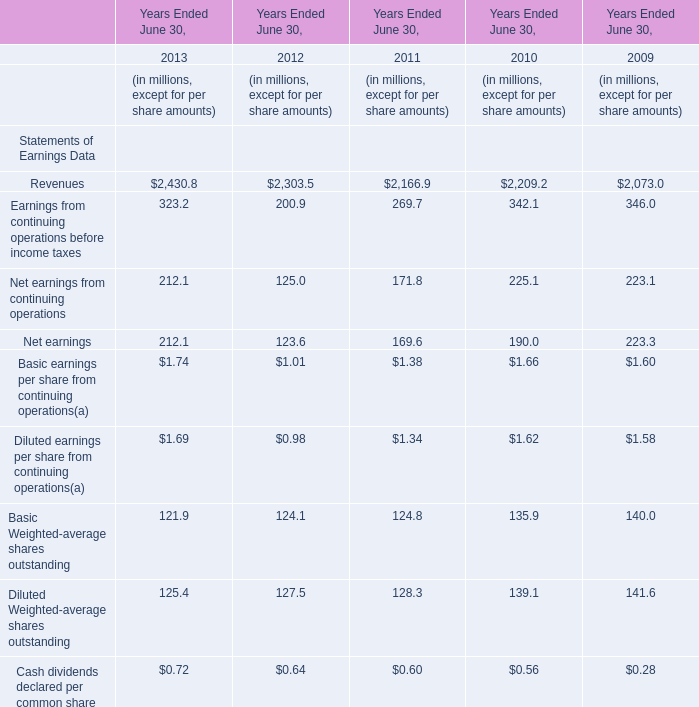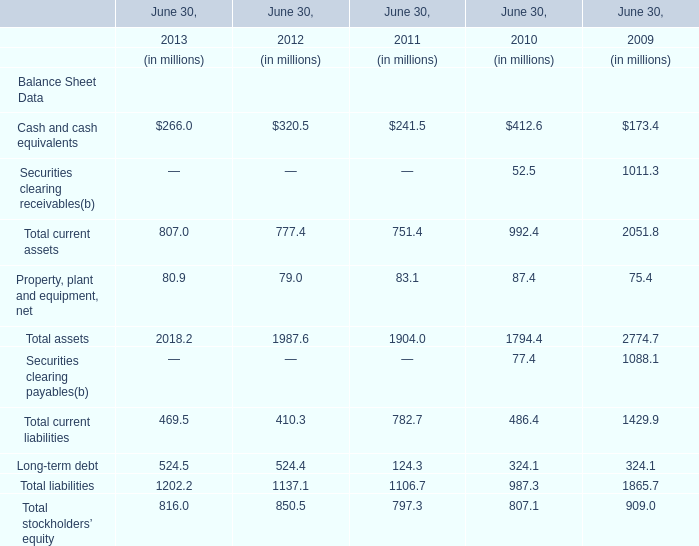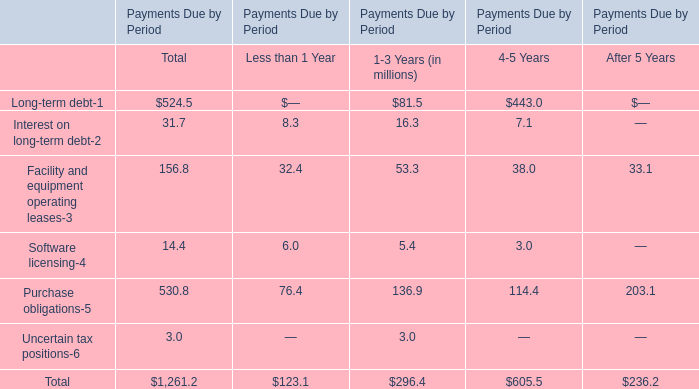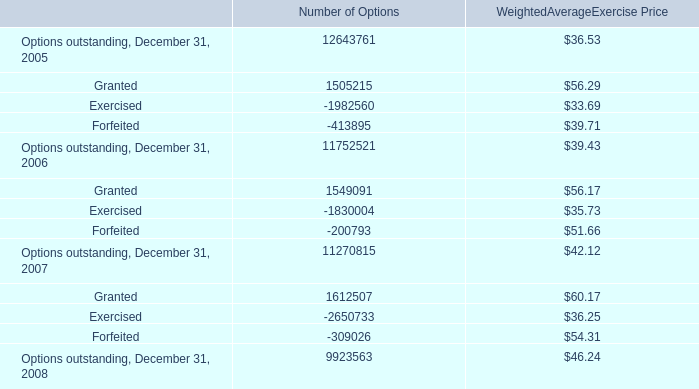In what year is Net earnings greater than 170? 
Answer: 201320102009. 